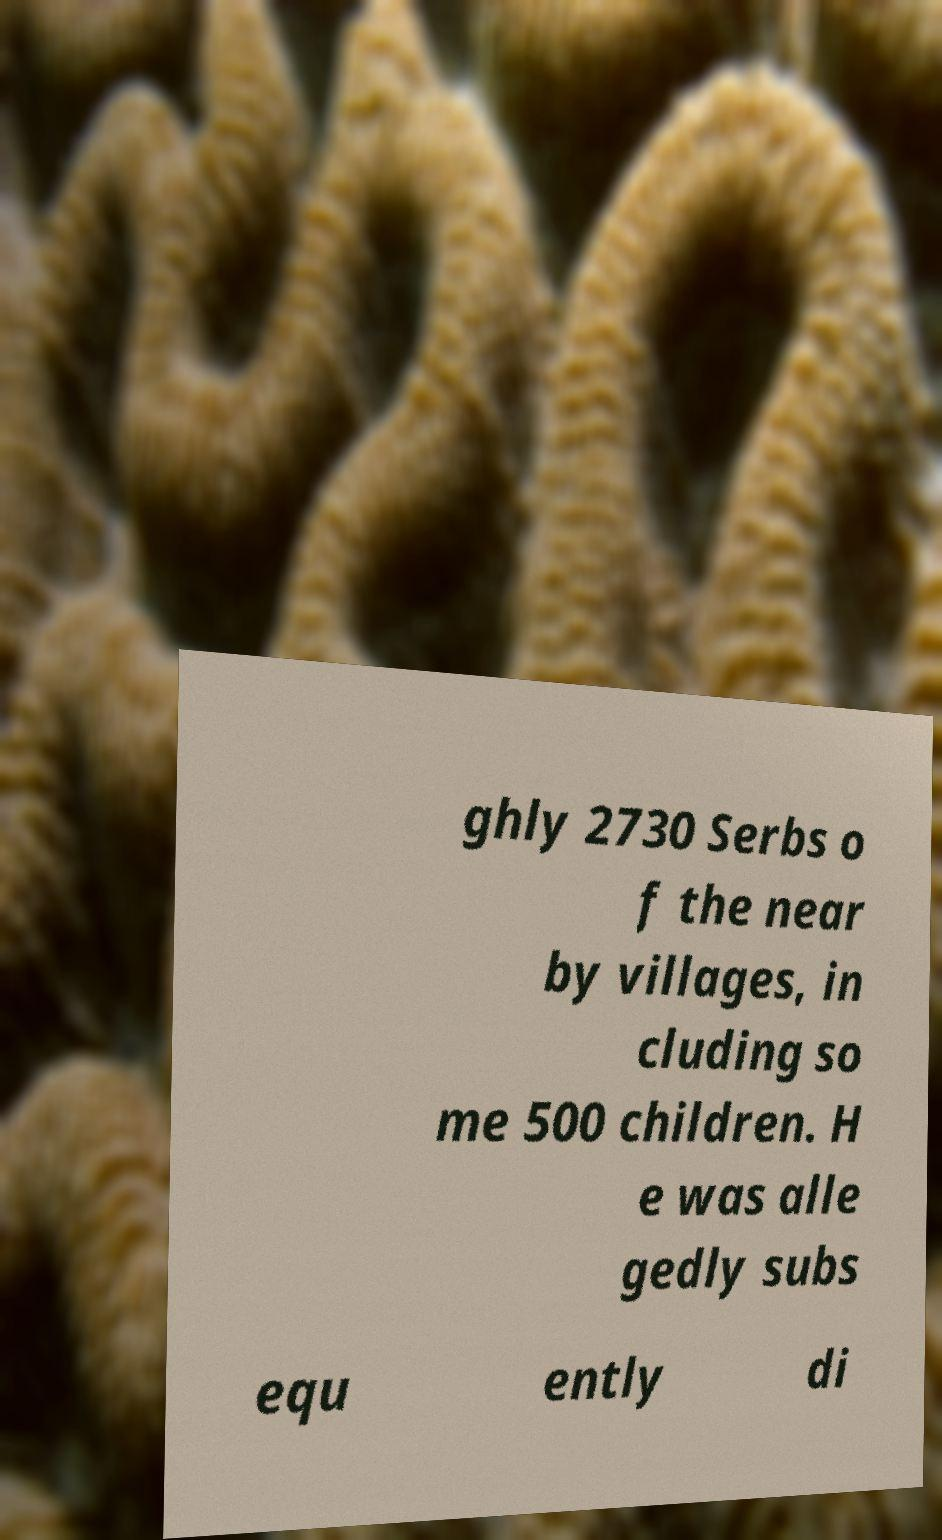For documentation purposes, I need the text within this image transcribed. Could you provide that? ghly 2730 Serbs o f the near by villages, in cluding so me 500 children. H e was alle gedly subs equ ently di 